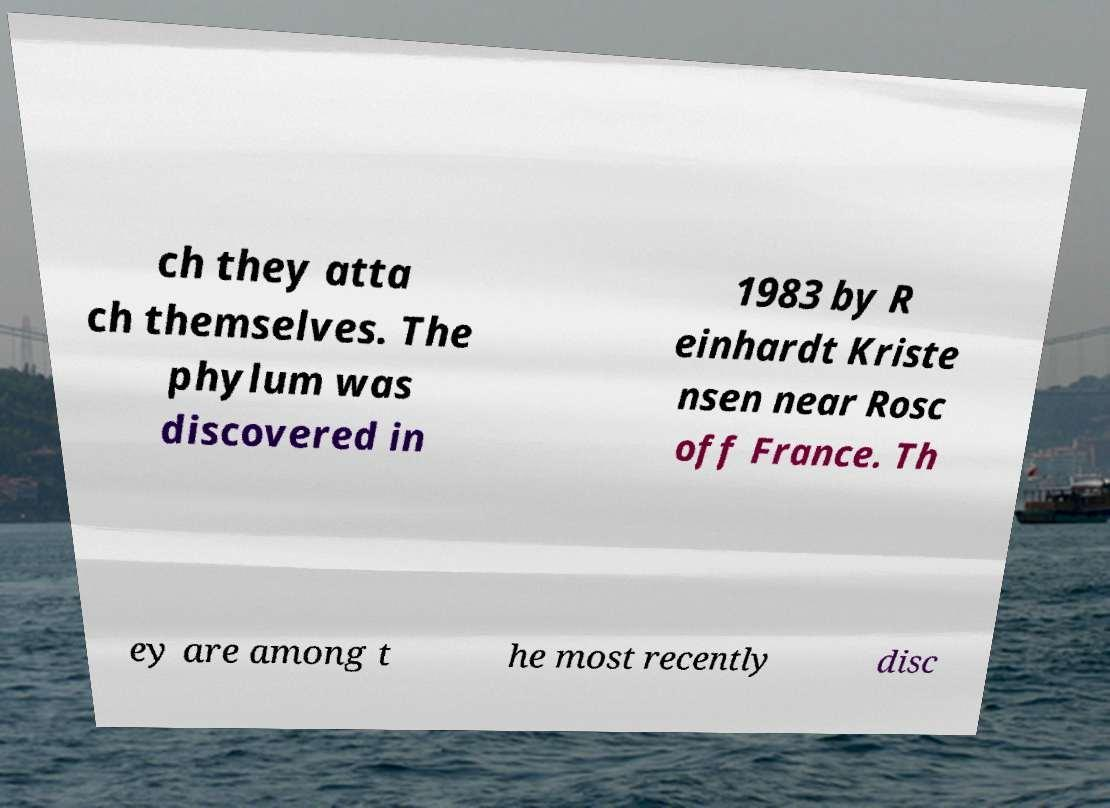Could you extract and type out the text from this image? ch they atta ch themselves. The phylum was discovered in 1983 by R einhardt Kriste nsen near Rosc off France. Th ey are among t he most recently disc 